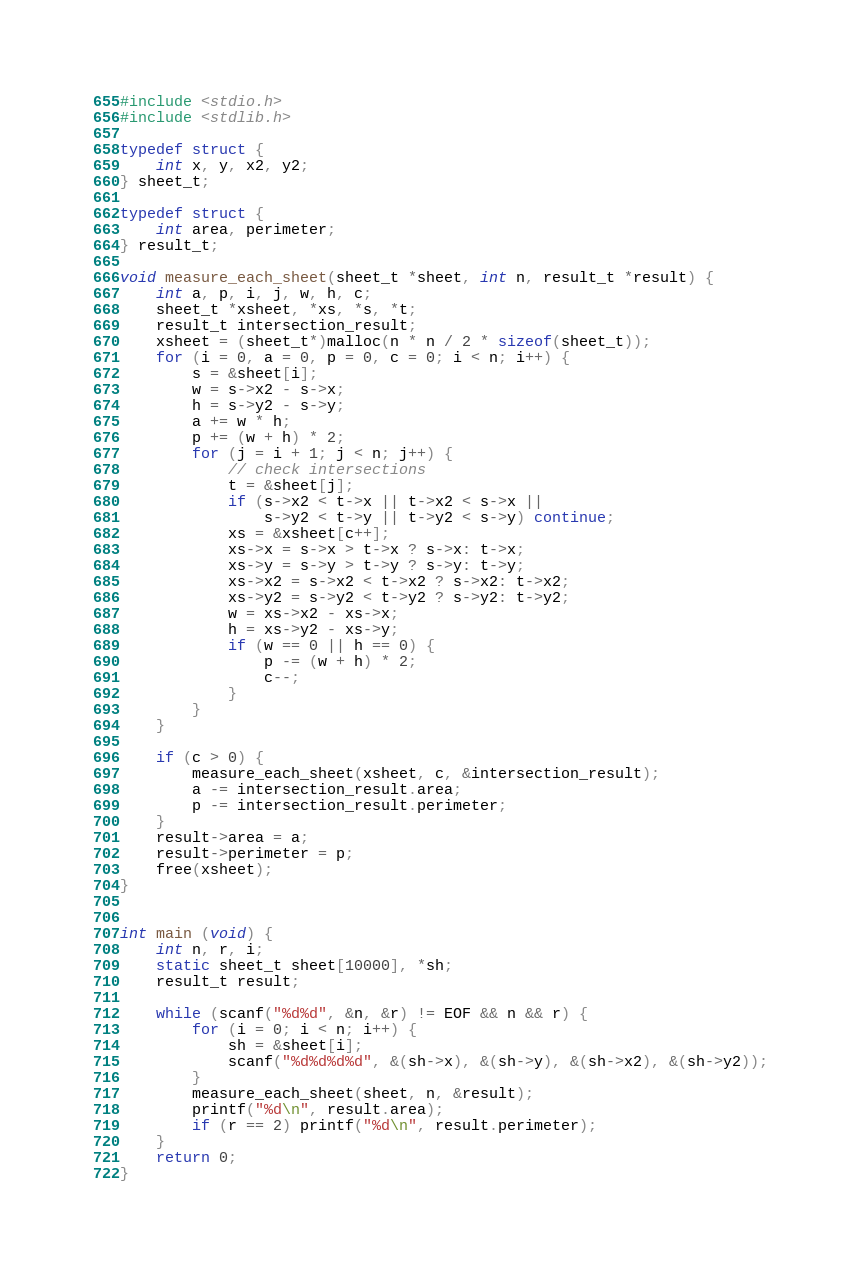Convert code to text. <code><loc_0><loc_0><loc_500><loc_500><_C_>#include <stdio.h>
#include <stdlib.h>

typedef struct {
    int x, y, x2, y2;
} sheet_t;

typedef struct {
    int area, perimeter;
} result_t;

void measure_each_sheet(sheet_t *sheet, int n, result_t *result) {
    int a, p, i, j, w, h, c;
    sheet_t *xsheet, *xs, *s, *t;
    result_t intersection_result;
    xsheet = (sheet_t*)malloc(n * n / 2 * sizeof(sheet_t));
    for (i = 0, a = 0, p = 0, c = 0; i < n; i++) {
        s = &sheet[i];
        w = s->x2 - s->x;
        h = s->y2 - s->y;
        a += w * h;
        p += (w + h) * 2;
        for (j = i + 1; j < n; j++) {
            // check intersections
            t = &sheet[j];
            if (s->x2 < t->x || t->x2 < s->x ||
                s->y2 < t->y || t->y2 < s->y) continue;
            xs = &xsheet[c++];
            xs->x = s->x > t->x ? s->x: t->x;
            xs->y = s->y > t->y ? s->y: t->y;
            xs->x2 = s->x2 < t->x2 ? s->x2: t->x2;
            xs->y2 = s->y2 < t->y2 ? s->y2: t->y2;
            w = xs->x2 - xs->x;
            h = xs->y2 - xs->y;
            if (w == 0 || h == 0) {
                p -= (w + h) * 2;
                c--;
            }
        }
    }

    if (c > 0) {
        measure_each_sheet(xsheet, c, &intersection_result);
        a -= intersection_result.area;
        p -= intersection_result.perimeter;
    }
    result->area = a;
    result->perimeter = p;
    free(xsheet);
}


int main (void) {
    int n, r, i;
    static sheet_t sheet[10000], *sh;
    result_t result;

    while (scanf("%d%d", &n, &r) != EOF && n && r) {
        for (i = 0; i < n; i++) {
            sh = &sheet[i];
            scanf("%d%d%d%d", &(sh->x), &(sh->y), &(sh->x2), &(sh->y2));
        }
        measure_each_sheet(sheet, n, &result);
        printf("%d\n", result.area);
        if (r == 2) printf("%d\n", result.perimeter);
    }
    return 0;
}</code> 